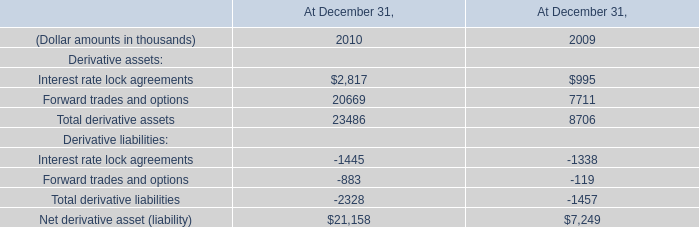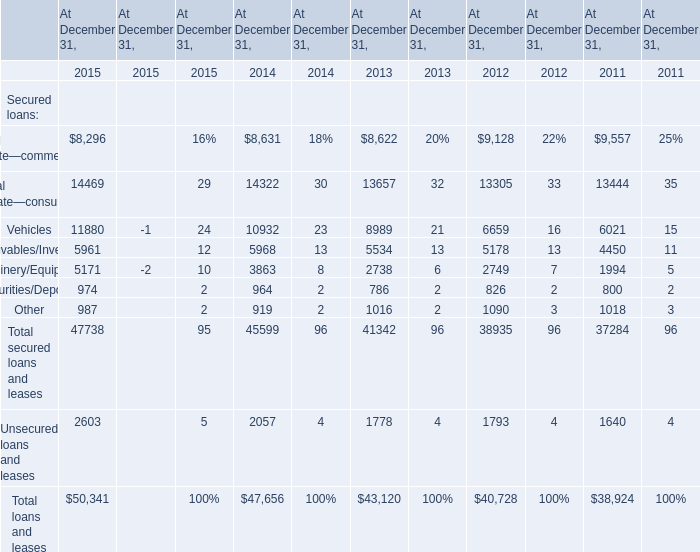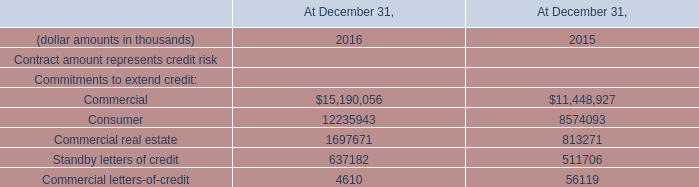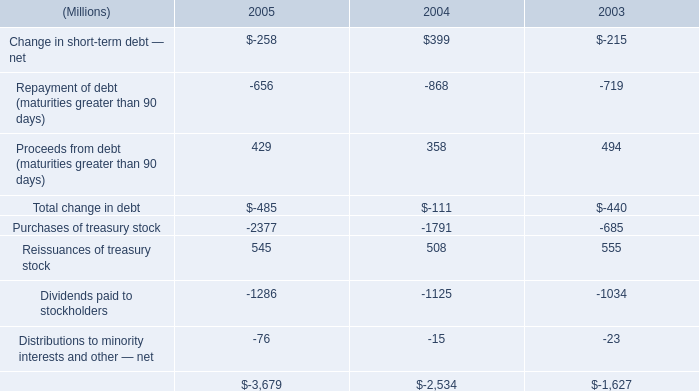In the year with the most Commercial letters-of-credit for Commitments to extend credit, what is the growth rate of Securities/Deposits for Secured loans? 
Computations: ((974 - 964) / 964)
Answer: 0.01037. 